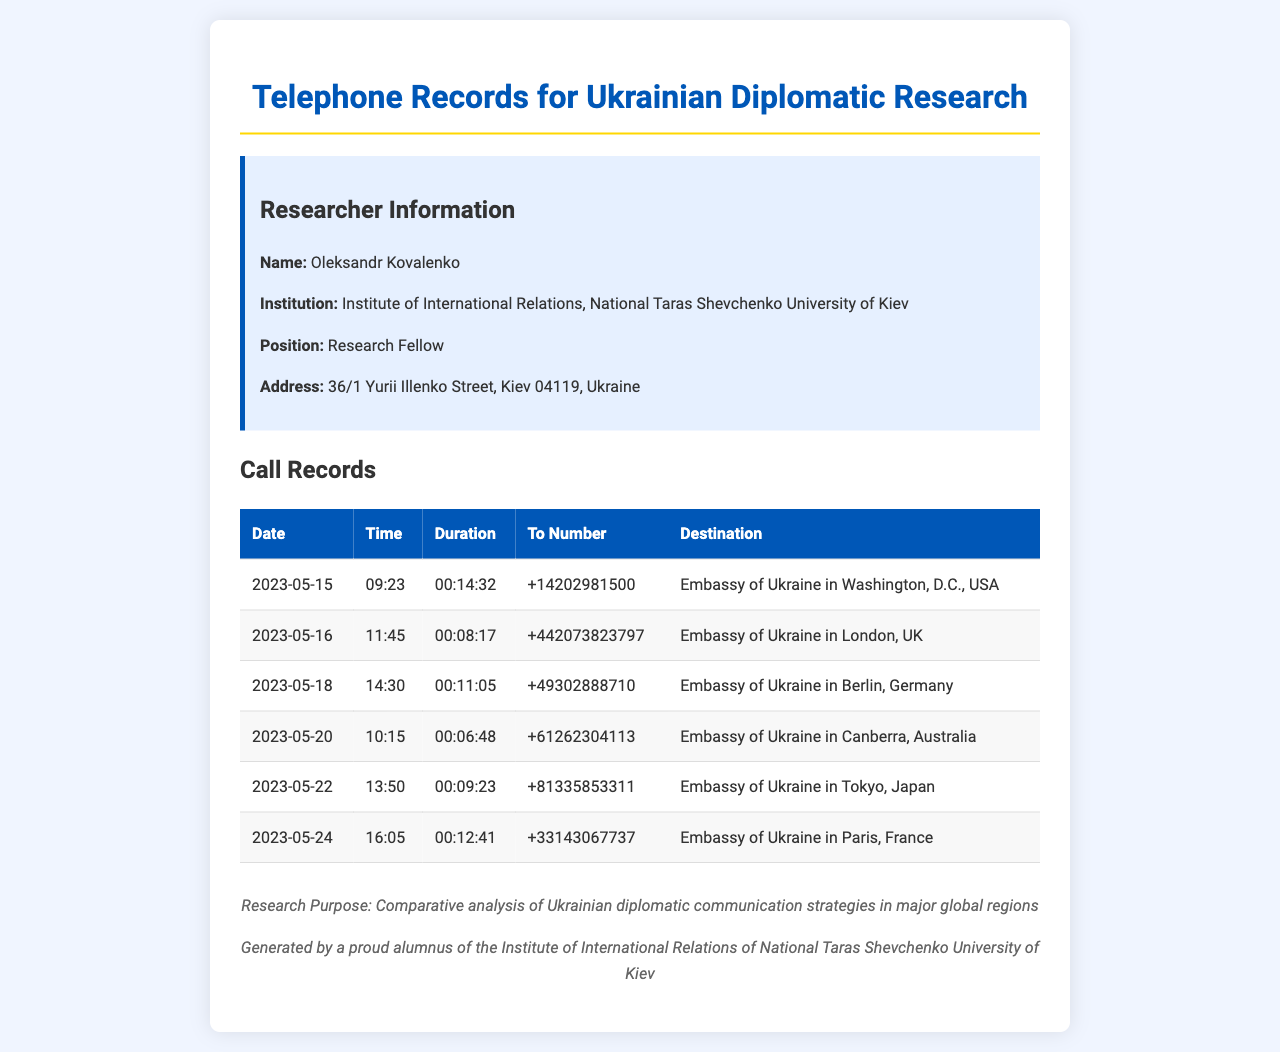what is the date of the first call? The first call is recorded on May 15, 2023.
Answer: May 15, 2023 how long was the call to the Embassy of Ukraine in Berlin? The call duration to the Embassy of Ukraine in Berlin was recorded as 11 minutes and 5 seconds.
Answer: 00:11:05 which embassy was called on May 22? The call on May 22 was made to the Embassy of Ukraine in Tokyo, Japan.
Answer: Embassy of Ukraine in Tokyo, Japan what is the destination of the call made at 09:23? The destination of the call made at 09:23 was the Embassy of Ukraine in Washington, D.C., USA.
Answer: Embassy of Ukraine in Washington, D.C., USA how many calls were made on May 2023? There were six calls made in May 2023.
Answer: Six what time was the call to the Embassy of Ukraine in Paris? The call to the Embassy of Ukraine in Paris was made at 16:05.
Answer: 16:05 what is the researcher’s name? The researcher’s name is Oleksandr Kovalenko.
Answer: Oleksandr Kovalenko which embassy is located in Canberra, Australia? The embassy located in Canberra, Australia is the Embassy of Ukraine.
Answer: Embassy of Ukraine in Canberra, Australia what was the total duration of all calls made? The total duration can be calculated by adding each call's duration together.
Answer: (requires calculation) 